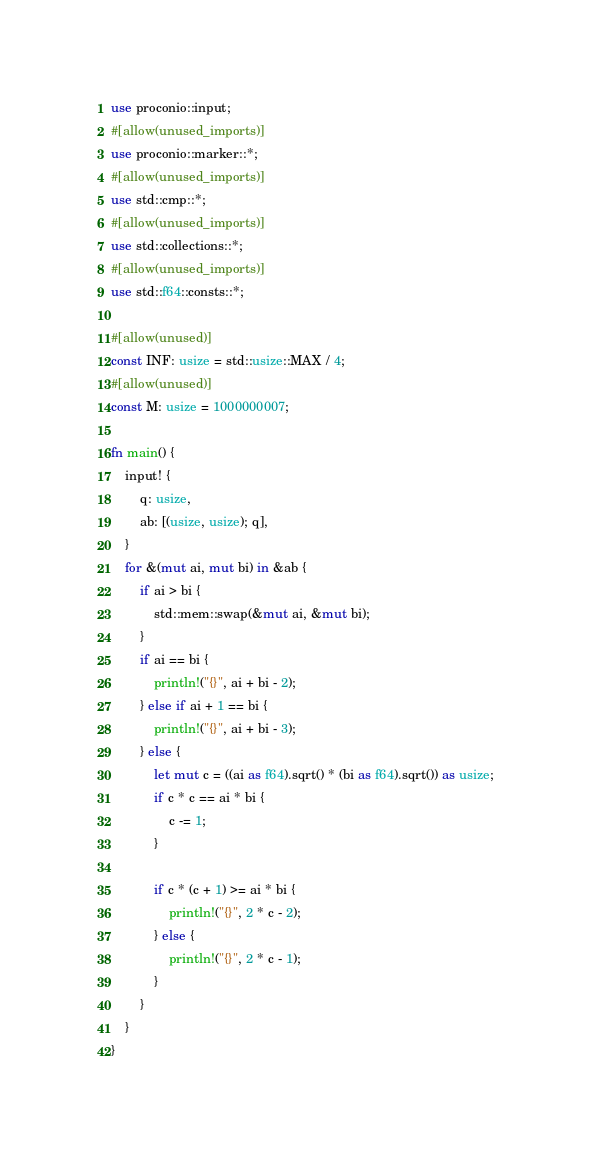Convert code to text. <code><loc_0><loc_0><loc_500><loc_500><_Rust_>use proconio::input;
#[allow(unused_imports)]
use proconio::marker::*;
#[allow(unused_imports)]
use std::cmp::*;
#[allow(unused_imports)]
use std::collections::*;
#[allow(unused_imports)]
use std::f64::consts::*;

#[allow(unused)]
const INF: usize = std::usize::MAX / 4;
#[allow(unused)]
const M: usize = 1000000007;

fn main() {
    input! {
        q: usize,
        ab: [(usize, usize); q],
    }
    for &(mut ai, mut bi) in &ab {
        if ai > bi {
            std::mem::swap(&mut ai, &mut bi);
        }
        if ai == bi {
            println!("{}", ai + bi - 2);
        } else if ai + 1 == bi {
            println!("{}", ai + bi - 3);
        } else {
            let mut c = ((ai as f64).sqrt() * (bi as f64).sqrt()) as usize;
            if c * c == ai * bi {
                c -= 1;
            }

            if c * (c + 1) >= ai * bi {
                println!("{}", 2 * c - 2);
            } else {
                println!("{}", 2 * c - 1);
            }
        }
    }
}
</code> 